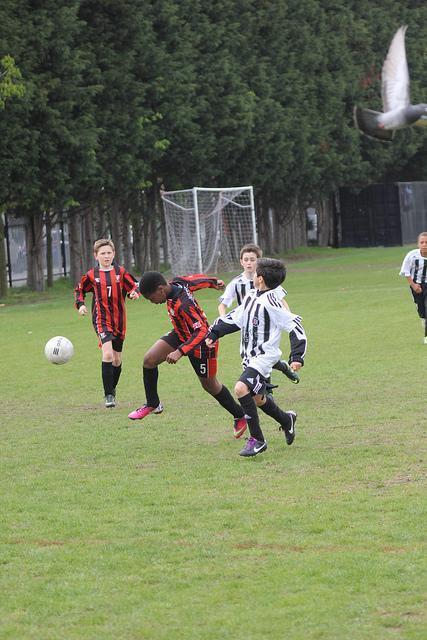How many red striped shirts?
Give a very brief answer. 2. How many people have their feet completely off the ground?
Give a very brief answer. 1. How many people can you see?
Give a very brief answer. 3. 